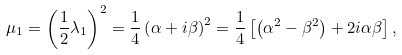Convert formula to latex. <formula><loc_0><loc_0><loc_500><loc_500>\mu _ { 1 } = \left ( \frac { 1 } { 2 } \lambda _ { 1 } \right ) ^ { 2 } = \frac { 1 } { 4 } \left ( \alpha + i \beta \right ) ^ { 2 } = \frac { 1 } { 4 } \left [ \left ( \alpha ^ { 2 } - \beta ^ { 2 } \right ) + 2 i \alpha \beta \right ] ,</formula> 